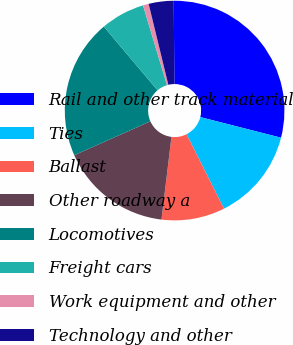Convert chart to OTSL. <chart><loc_0><loc_0><loc_500><loc_500><pie_chart><fcel>Rail and other track material<fcel>Ties<fcel>Ballast<fcel>Other roadway a<fcel>Locomotives<fcel>Freight cars<fcel>Work equipment and other<fcel>Technology and other<nl><fcel>29.1%<fcel>13.6%<fcel>9.33%<fcel>16.43%<fcel>20.51%<fcel>6.5%<fcel>0.85%<fcel>3.67%<nl></chart> 